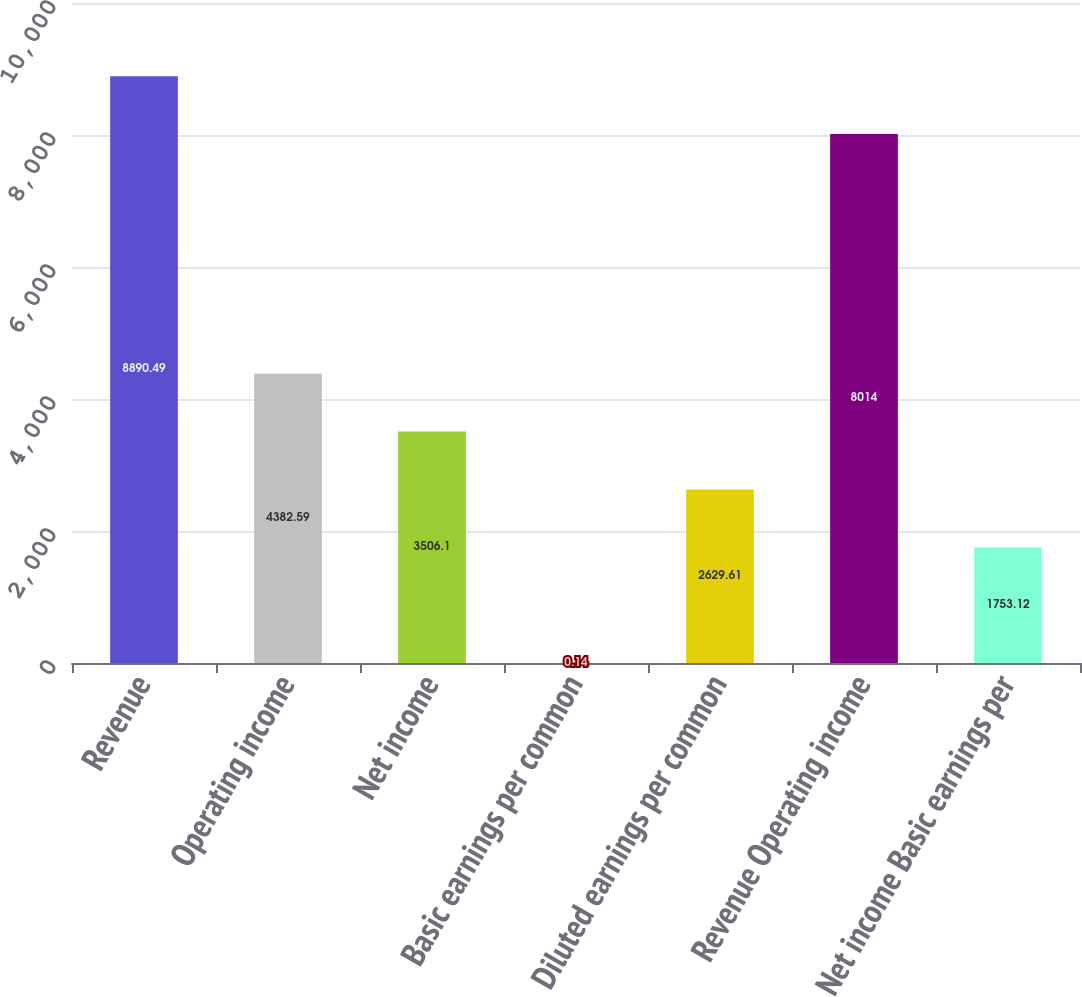<chart> <loc_0><loc_0><loc_500><loc_500><bar_chart><fcel>Revenue<fcel>Operating income<fcel>Net income<fcel>Basic earnings per common<fcel>Diluted earnings per common<fcel>Revenue Operating income<fcel>Net income Basic earnings per<nl><fcel>8890.49<fcel>4382.59<fcel>3506.1<fcel>0.14<fcel>2629.61<fcel>8014<fcel>1753.12<nl></chart> 